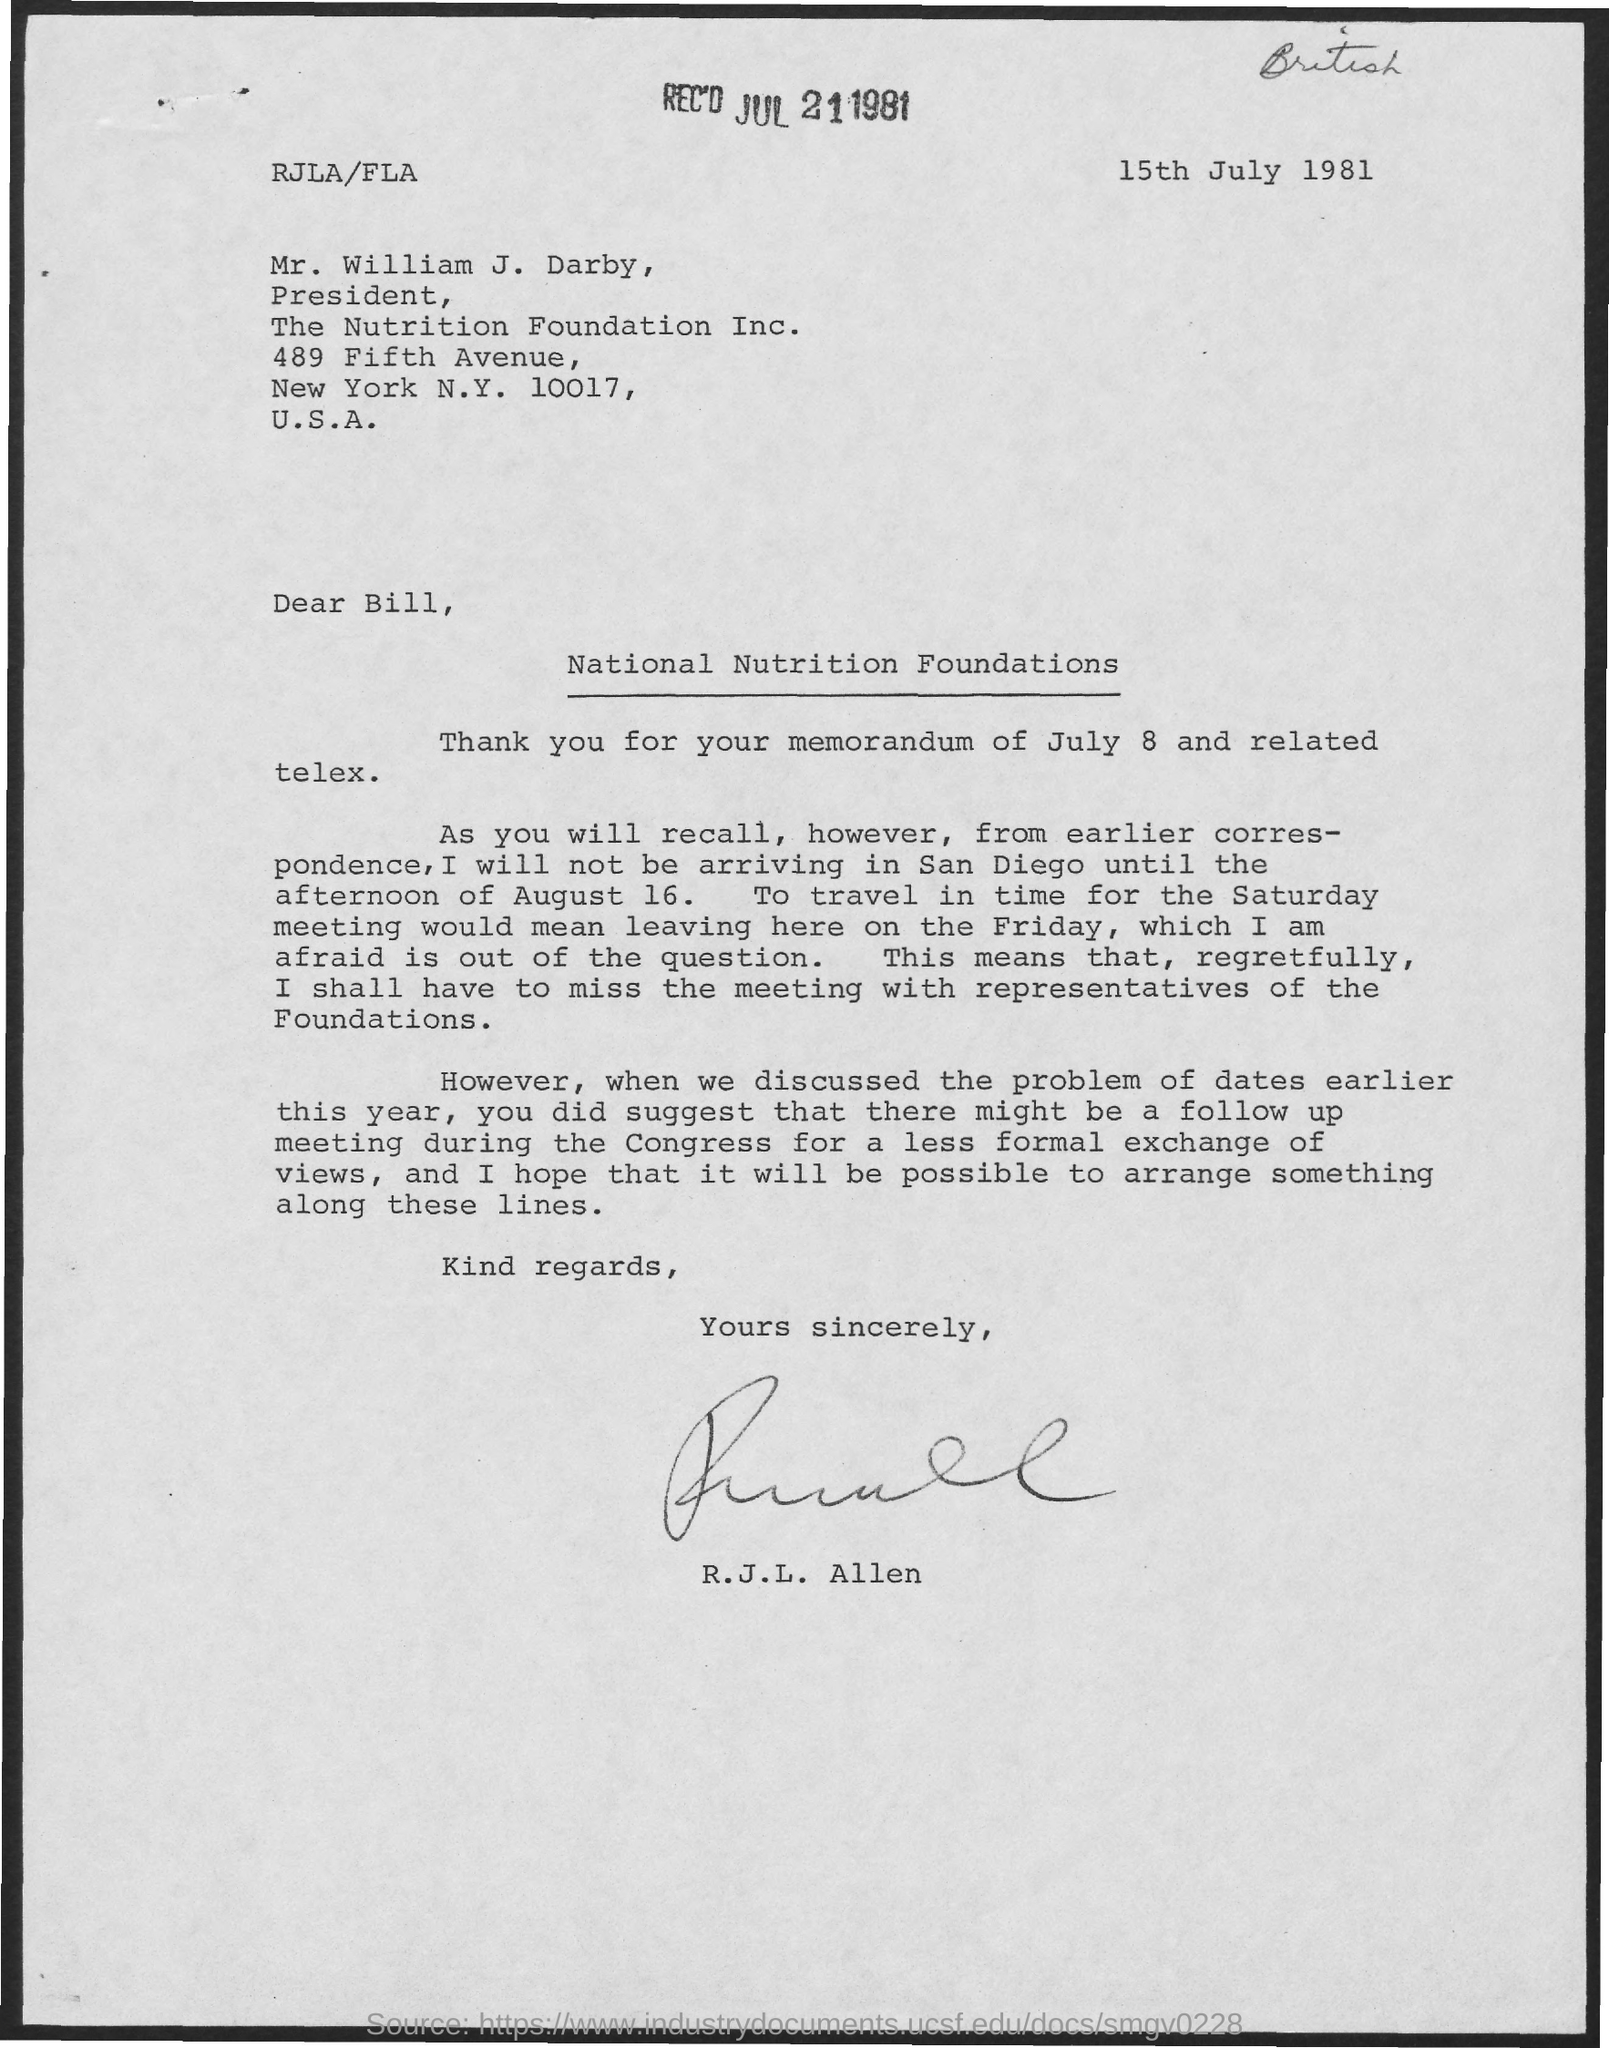In which country  the nutrition foundation is located?
Provide a succinct answer. U.S.A. What is the new york code mentioned in the letter?
Ensure brevity in your answer.  10017. On which day allen wrote the letter?
Your answer should be very brief. 15th July 1981. 